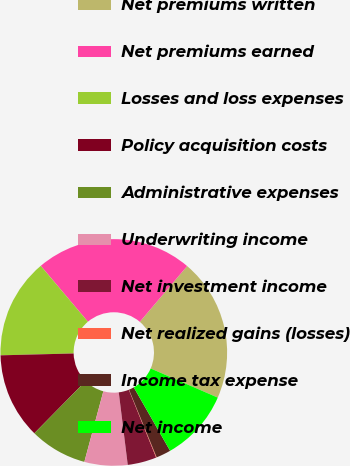Convert chart to OTSL. <chart><loc_0><loc_0><loc_500><loc_500><pie_chart><fcel>Net premiums written<fcel>Net premiums earned<fcel>Losses and loss expenses<fcel>Policy acquisition costs<fcel>Administrative expenses<fcel>Underwriting income<fcel>Net investment income<fcel>Net realized gains (losses)<fcel>Income tax expense<fcel>Net income<nl><fcel>20.32%<fcel>22.35%<fcel>14.25%<fcel>12.23%<fcel>8.18%<fcel>6.15%<fcel>4.13%<fcel>0.08%<fcel>2.1%<fcel>10.2%<nl></chart> 